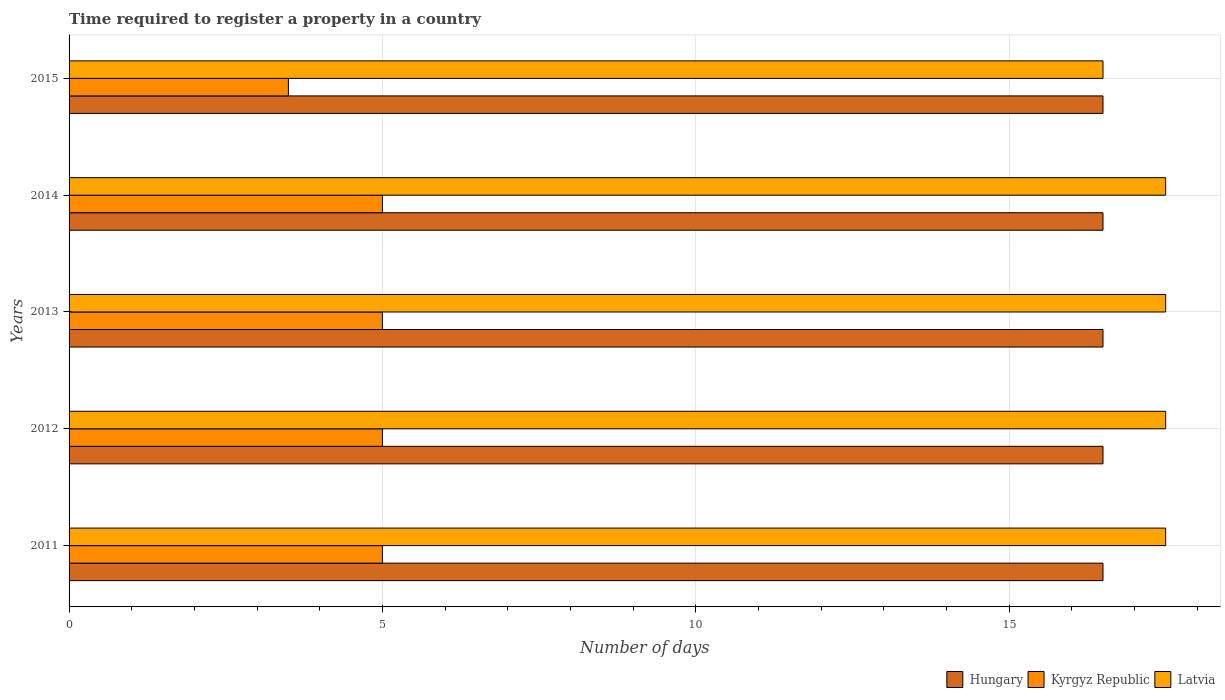How many different coloured bars are there?
Provide a succinct answer. 3. How many groups of bars are there?
Keep it short and to the point. 5. Are the number of bars per tick equal to the number of legend labels?
Provide a succinct answer. Yes. How many bars are there on the 4th tick from the top?
Your answer should be very brief. 3. Across all years, what is the maximum number of days required to register a property in Hungary?
Give a very brief answer. 16.5. Across all years, what is the minimum number of days required to register a property in Latvia?
Your answer should be very brief. 16.5. What is the total number of days required to register a property in Hungary in the graph?
Your answer should be very brief. 82.5. What is the average number of days required to register a property in Latvia per year?
Your response must be concise. 17.3. In the year 2015, what is the difference between the number of days required to register a property in Kyrgyz Republic and number of days required to register a property in Hungary?
Offer a terse response. -13. What is the ratio of the number of days required to register a property in Hungary in 2011 to that in 2015?
Your response must be concise. 1. What is the difference between the highest and the lowest number of days required to register a property in Hungary?
Your answer should be compact. 0. Is the sum of the number of days required to register a property in Kyrgyz Republic in 2012 and 2013 greater than the maximum number of days required to register a property in Latvia across all years?
Offer a terse response. No. What does the 2nd bar from the top in 2015 represents?
Provide a succinct answer. Kyrgyz Republic. What does the 3rd bar from the bottom in 2014 represents?
Ensure brevity in your answer.  Latvia. Is it the case that in every year, the sum of the number of days required to register a property in Kyrgyz Republic and number of days required to register a property in Hungary is greater than the number of days required to register a property in Latvia?
Offer a very short reply. Yes. How many bars are there?
Provide a short and direct response. 15. Does the graph contain grids?
Keep it short and to the point. Yes. Where does the legend appear in the graph?
Offer a very short reply. Bottom right. What is the title of the graph?
Give a very brief answer. Time required to register a property in a country. Does "Guam" appear as one of the legend labels in the graph?
Ensure brevity in your answer.  No. What is the label or title of the X-axis?
Ensure brevity in your answer.  Number of days. What is the Number of days of Hungary in 2011?
Keep it short and to the point. 16.5. What is the Number of days in Kyrgyz Republic in 2012?
Provide a short and direct response. 5. What is the Number of days of Hungary in 2013?
Make the answer very short. 16.5. What is the Number of days of Kyrgyz Republic in 2013?
Make the answer very short. 5. What is the Number of days of Hungary in 2014?
Ensure brevity in your answer.  16.5. What is the Number of days of Kyrgyz Republic in 2014?
Provide a short and direct response. 5. What is the Number of days of Latvia in 2014?
Give a very brief answer. 17.5. What is the Number of days of Hungary in 2015?
Your answer should be very brief. 16.5. What is the Number of days of Latvia in 2015?
Provide a short and direct response. 16.5. Across all years, what is the maximum Number of days of Latvia?
Make the answer very short. 17.5. What is the total Number of days of Hungary in the graph?
Keep it short and to the point. 82.5. What is the total Number of days in Latvia in the graph?
Your answer should be compact. 86.5. What is the difference between the Number of days in Latvia in 2011 and that in 2012?
Offer a terse response. 0. What is the difference between the Number of days in Hungary in 2011 and that in 2014?
Provide a short and direct response. 0. What is the difference between the Number of days of Kyrgyz Republic in 2011 and that in 2014?
Make the answer very short. 0. What is the difference between the Number of days in Latvia in 2012 and that in 2013?
Offer a very short reply. 0. What is the difference between the Number of days in Hungary in 2012 and that in 2014?
Your response must be concise. 0. What is the difference between the Number of days in Latvia in 2012 and that in 2014?
Your answer should be compact. 0. What is the difference between the Number of days in Hungary in 2013 and that in 2014?
Give a very brief answer. 0. What is the difference between the Number of days of Kyrgyz Republic in 2013 and that in 2014?
Ensure brevity in your answer.  0. What is the difference between the Number of days in Kyrgyz Republic in 2013 and that in 2015?
Keep it short and to the point. 1.5. What is the difference between the Number of days in Hungary in 2011 and the Number of days in Latvia in 2012?
Make the answer very short. -1. What is the difference between the Number of days of Hungary in 2011 and the Number of days of Kyrgyz Republic in 2013?
Your answer should be compact. 11.5. What is the difference between the Number of days in Kyrgyz Republic in 2011 and the Number of days in Latvia in 2013?
Your response must be concise. -12.5. What is the difference between the Number of days of Hungary in 2011 and the Number of days of Kyrgyz Republic in 2014?
Your response must be concise. 11.5. What is the difference between the Number of days in Hungary in 2011 and the Number of days in Kyrgyz Republic in 2015?
Give a very brief answer. 13. What is the difference between the Number of days in Hungary in 2011 and the Number of days in Latvia in 2015?
Your response must be concise. 0. What is the difference between the Number of days in Hungary in 2012 and the Number of days in Kyrgyz Republic in 2013?
Your response must be concise. 11.5. What is the difference between the Number of days in Kyrgyz Republic in 2012 and the Number of days in Latvia in 2013?
Your answer should be very brief. -12.5. What is the difference between the Number of days in Kyrgyz Republic in 2012 and the Number of days in Latvia in 2014?
Make the answer very short. -12.5. What is the difference between the Number of days in Hungary in 2012 and the Number of days in Kyrgyz Republic in 2015?
Provide a short and direct response. 13. What is the difference between the Number of days in Hungary in 2013 and the Number of days in Latvia in 2014?
Keep it short and to the point. -1. What is the difference between the Number of days in Kyrgyz Republic in 2013 and the Number of days in Latvia in 2014?
Offer a terse response. -12.5. What is the difference between the Number of days in Hungary in 2013 and the Number of days in Latvia in 2015?
Offer a very short reply. 0. What is the difference between the Number of days in Hungary in 2014 and the Number of days in Kyrgyz Republic in 2015?
Offer a very short reply. 13. What is the difference between the Number of days of Hungary in 2014 and the Number of days of Latvia in 2015?
Offer a terse response. 0. What is the average Number of days in Hungary per year?
Offer a terse response. 16.5. What is the average Number of days in Kyrgyz Republic per year?
Ensure brevity in your answer.  4.7. In the year 2011, what is the difference between the Number of days of Hungary and Number of days of Kyrgyz Republic?
Give a very brief answer. 11.5. In the year 2011, what is the difference between the Number of days of Kyrgyz Republic and Number of days of Latvia?
Offer a terse response. -12.5. In the year 2012, what is the difference between the Number of days in Hungary and Number of days in Latvia?
Your answer should be very brief. -1. In the year 2012, what is the difference between the Number of days in Kyrgyz Republic and Number of days in Latvia?
Your answer should be compact. -12.5. In the year 2013, what is the difference between the Number of days of Hungary and Number of days of Kyrgyz Republic?
Offer a very short reply. 11.5. In the year 2014, what is the difference between the Number of days in Hungary and Number of days in Kyrgyz Republic?
Your answer should be very brief. 11.5. In the year 2014, what is the difference between the Number of days in Hungary and Number of days in Latvia?
Give a very brief answer. -1. In the year 2014, what is the difference between the Number of days in Kyrgyz Republic and Number of days in Latvia?
Offer a very short reply. -12.5. In the year 2015, what is the difference between the Number of days of Hungary and Number of days of Latvia?
Make the answer very short. 0. What is the ratio of the Number of days in Hungary in 2011 to that in 2012?
Offer a terse response. 1. What is the ratio of the Number of days of Kyrgyz Republic in 2011 to that in 2012?
Offer a terse response. 1. What is the ratio of the Number of days of Latvia in 2011 to that in 2012?
Make the answer very short. 1. What is the ratio of the Number of days of Hungary in 2011 to that in 2013?
Your answer should be very brief. 1. What is the ratio of the Number of days of Hungary in 2011 to that in 2014?
Your response must be concise. 1. What is the ratio of the Number of days of Latvia in 2011 to that in 2014?
Provide a short and direct response. 1. What is the ratio of the Number of days in Kyrgyz Republic in 2011 to that in 2015?
Your answer should be compact. 1.43. What is the ratio of the Number of days of Latvia in 2011 to that in 2015?
Your answer should be very brief. 1.06. What is the ratio of the Number of days of Hungary in 2012 to that in 2013?
Offer a very short reply. 1. What is the ratio of the Number of days of Kyrgyz Republic in 2012 to that in 2013?
Offer a very short reply. 1. What is the ratio of the Number of days of Hungary in 2012 to that in 2014?
Your answer should be very brief. 1. What is the ratio of the Number of days of Kyrgyz Republic in 2012 to that in 2014?
Offer a terse response. 1. What is the ratio of the Number of days of Hungary in 2012 to that in 2015?
Your answer should be very brief. 1. What is the ratio of the Number of days of Kyrgyz Republic in 2012 to that in 2015?
Offer a very short reply. 1.43. What is the ratio of the Number of days of Latvia in 2012 to that in 2015?
Your response must be concise. 1.06. What is the ratio of the Number of days in Hungary in 2013 to that in 2014?
Your response must be concise. 1. What is the ratio of the Number of days in Kyrgyz Republic in 2013 to that in 2015?
Make the answer very short. 1.43. What is the ratio of the Number of days in Latvia in 2013 to that in 2015?
Your answer should be compact. 1.06. What is the ratio of the Number of days of Kyrgyz Republic in 2014 to that in 2015?
Your response must be concise. 1.43. What is the ratio of the Number of days of Latvia in 2014 to that in 2015?
Provide a short and direct response. 1.06. What is the difference between the highest and the second highest Number of days in Kyrgyz Republic?
Your answer should be compact. 0. What is the difference between the highest and the second highest Number of days in Latvia?
Offer a very short reply. 0. What is the difference between the highest and the lowest Number of days in Latvia?
Provide a short and direct response. 1. 